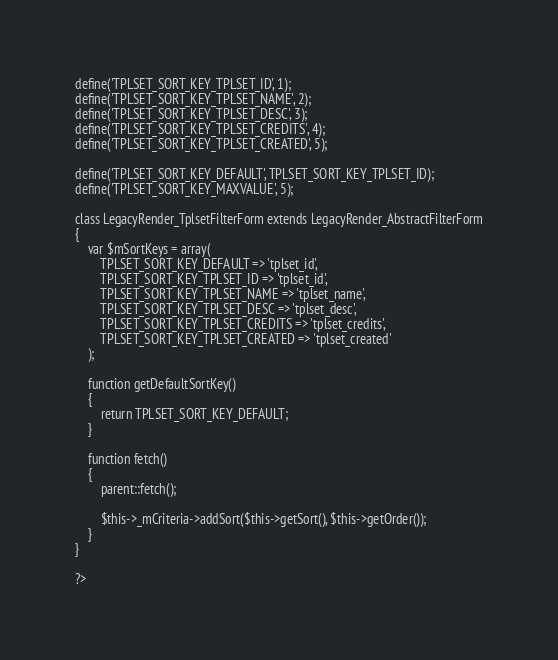Convert code to text. <code><loc_0><loc_0><loc_500><loc_500><_PHP_>
define('TPLSET_SORT_KEY_TPLSET_ID', 1);
define('TPLSET_SORT_KEY_TPLSET_NAME', 2);
define('TPLSET_SORT_KEY_TPLSET_DESC', 3);
define('TPLSET_SORT_KEY_TPLSET_CREDITS', 4);
define('TPLSET_SORT_KEY_TPLSET_CREATED', 5);

define('TPLSET_SORT_KEY_DEFAULT', TPLSET_SORT_KEY_TPLSET_ID);
define('TPLSET_SORT_KEY_MAXVALUE', 5);

class LegacyRender_TplsetFilterForm extends LegacyRender_AbstractFilterForm
{
	var $mSortKeys = array(
		TPLSET_SORT_KEY_DEFAULT => 'tplset_id',
		TPLSET_SORT_KEY_TPLSET_ID => 'tplset_id',
		TPLSET_SORT_KEY_TPLSET_NAME => 'tplset_name',
		TPLSET_SORT_KEY_TPLSET_DESC => 'tplset_desc',
		TPLSET_SORT_KEY_TPLSET_CREDITS => 'tplset_credits',
		TPLSET_SORT_KEY_TPLSET_CREATED => 'tplset_created'
	);
	
	function getDefaultSortKey()
	{
		return TPLSET_SORT_KEY_DEFAULT;
	}

	function fetch()
	{
		parent::fetch();
		
		$this->_mCriteria->addSort($this->getSort(), $this->getOrder());
	}
}

?>
</code> 